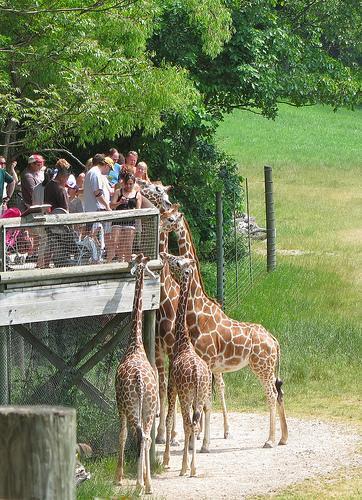How many giraffes are there?
Give a very brief answer. 4. How many baby giraffes are there?
Give a very brief answer. 2. 